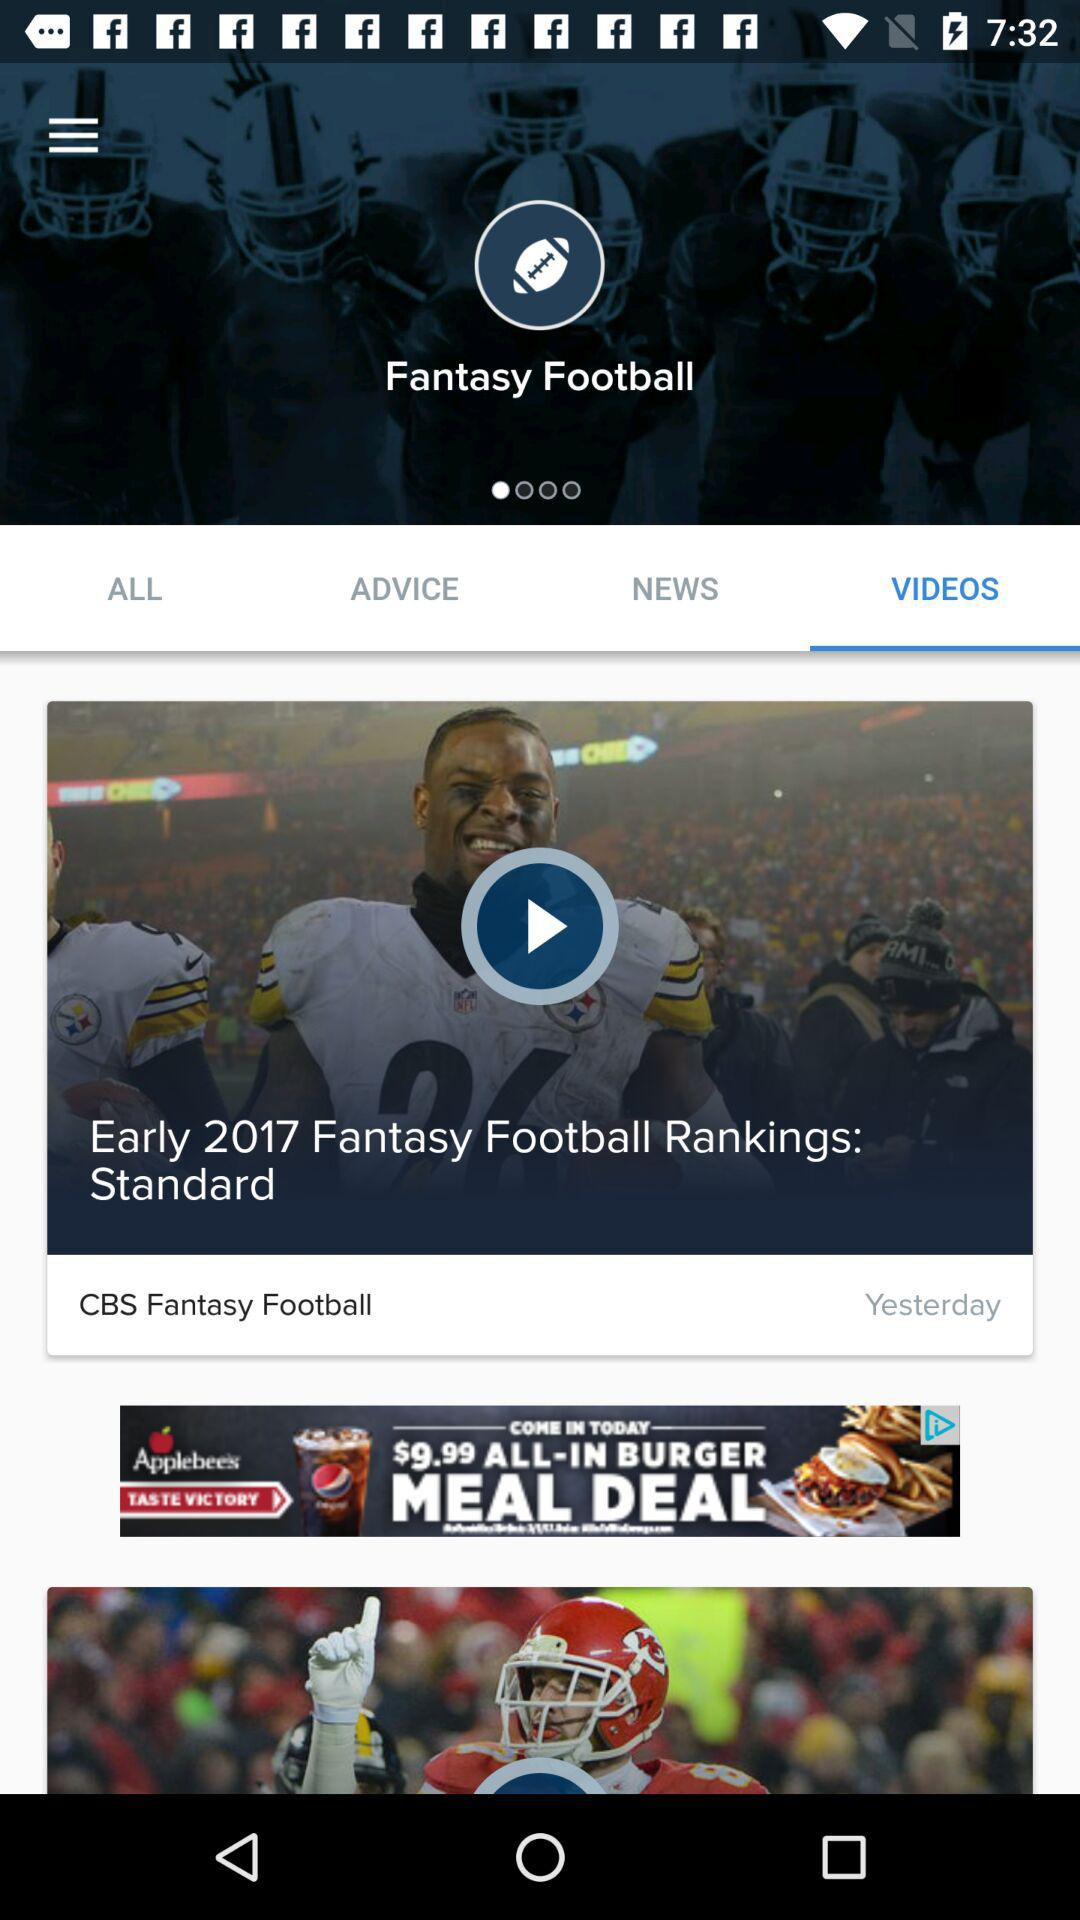When was the "CBS Fantasy Football" video released? The "CBS Fantasy Football" video was released yesterday. 